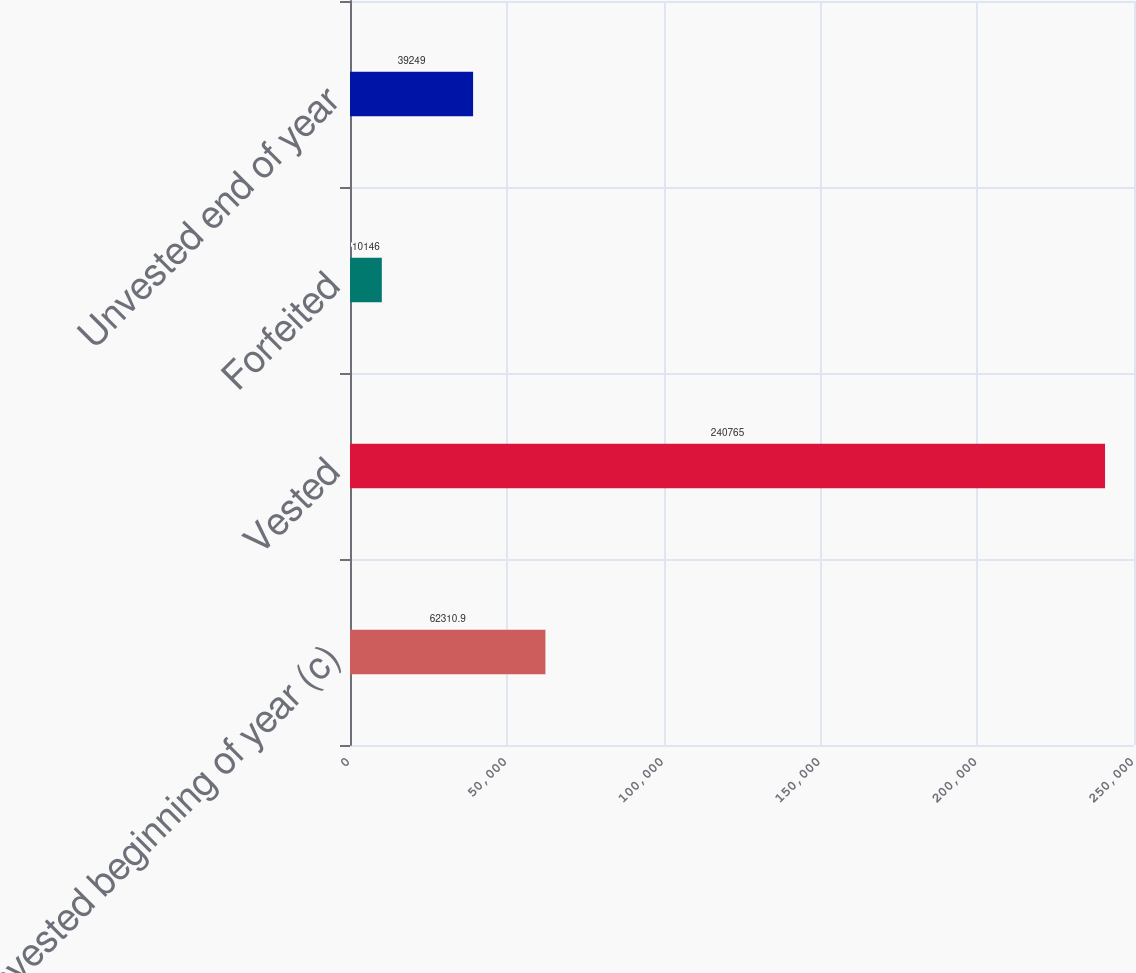<chart> <loc_0><loc_0><loc_500><loc_500><bar_chart><fcel>Unvested beginning of year (c)<fcel>Vested<fcel>Forfeited<fcel>Unvested end of year<nl><fcel>62310.9<fcel>240765<fcel>10146<fcel>39249<nl></chart> 